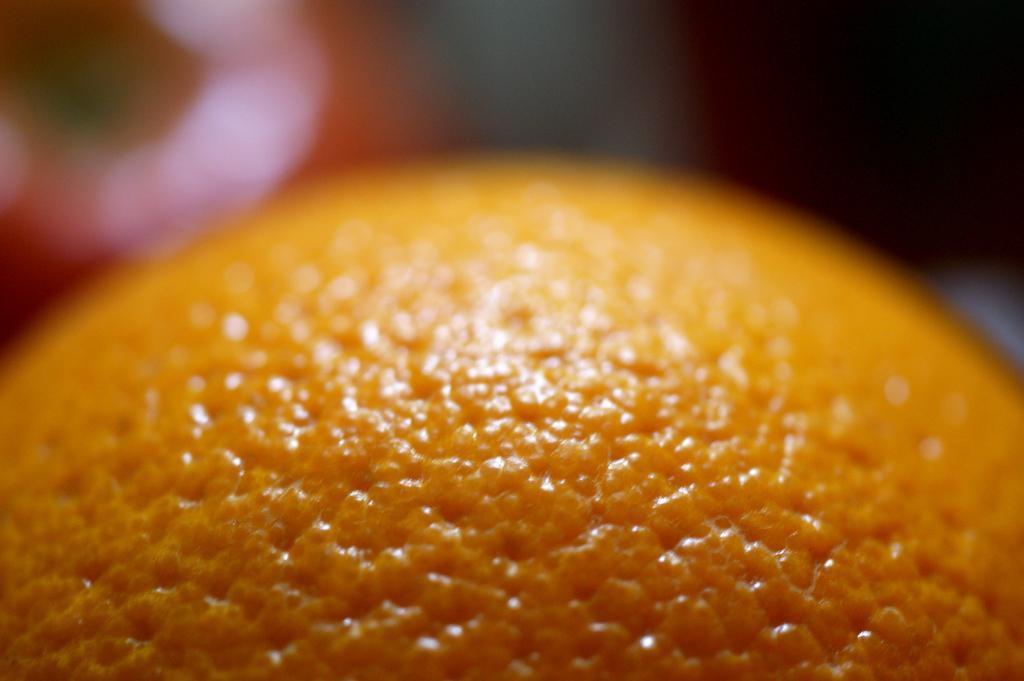Please provide a concise description of this image. In this image, we can see an orange. Top of the image, there is a blur view. 